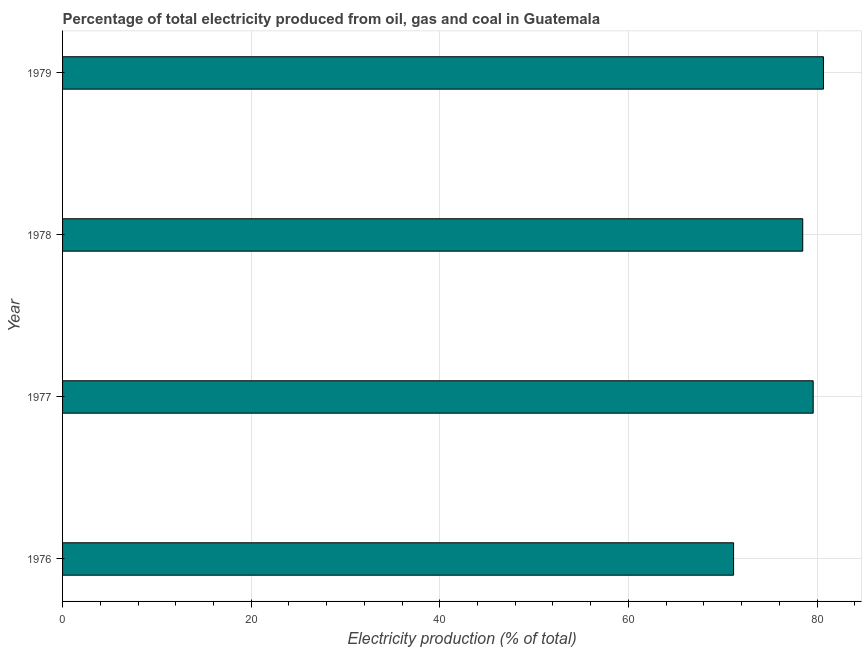Does the graph contain grids?
Provide a short and direct response. Yes. What is the title of the graph?
Keep it short and to the point. Percentage of total electricity produced from oil, gas and coal in Guatemala. What is the label or title of the X-axis?
Provide a succinct answer. Electricity production (% of total). What is the label or title of the Y-axis?
Your answer should be compact. Year. What is the electricity production in 1977?
Give a very brief answer. 79.59. Across all years, what is the maximum electricity production?
Your answer should be compact. 80.68. Across all years, what is the minimum electricity production?
Keep it short and to the point. 71.15. In which year was the electricity production maximum?
Your answer should be very brief. 1979. In which year was the electricity production minimum?
Provide a succinct answer. 1976. What is the sum of the electricity production?
Give a very brief answer. 309.9. What is the difference between the electricity production in 1976 and 1977?
Offer a terse response. -8.44. What is the average electricity production per year?
Make the answer very short. 77.47. What is the median electricity production?
Offer a very short reply. 79.04. In how many years, is the electricity production greater than 64 %?
Give a very brief answer. 4. Do a majority of the years between 1976 and 1979 (inclusive) have electricity production greater than 12 %?
Provide a short and direct response. Yes. What is the ratio of the electricity production in 1976 to that in 1978?
Give a very brief answer. 0.91. Is the electricity production in 1976 less than that in 1978?
Your answer should be very brief. Yes. Is the difference between the electricity production in 1978 and 1979 greater than the difference between any two years?
Give a very brief answer. No. What is the difference between the highest and the second highest electricity production?
Make the answer very short. 1.09. What is the difference between the highest and the lowest electricity production?
Your answer should be compact. 9.53. In how many years, is the electricity production greater than the average electricity production taken over all years?
Your answer should be very brief. 3. How many years are there in the graph?
Keep it short and to the point. 4. What is the difference between two consecutive major ticks on the X-axis?
Make the answer very short. 20. Are the values on the major ticks of X-axis written in scientific E-notation?
Provide a short and direct response. No. What is the Electricity production (% of total) in 1976?
Keep it short and to the point. 71.15. What is the Electricity production (% of total) in 1977?
Make the answer very short. 79.59. What is the Electricity production (% of total) in 1978?
Your answer should be compact. 78.48. What is the Electricity production (% of total) in 1979?
Ensure brevity in your answer.  80.68. What is the difference between the Electricity production (% of total) in 1976 and 1977?
Make the answer very short. -8.44. What is the difference between the Electricity production (% of total) in 1976 and 1978?
Give a very brief answer. -7.33. What is the difference between the Electricity production (% of total) in 1976 and 1979?
Offer a very short reply. -9.53. What is the difference between the Electricity production (% of total) in 1977 and 1978?
Ensure brevity in your answer.  1.11. What is the difference between the Electricity production (% of total) in 1977 and 1979?
Your answer should be compact. -1.09. What is the difference between the Electricity production (% of total) in 1978 and 1979?
Make the answer very short. -2.2. What is the ratio of the Electricity production (% of total) in 1976 to that in 1977?
Your answer should be compact. 0.89. What is the ratio of the Electricity production (% of total) in 1976 to that in 1978?
Your answer should be compact. 0.91. What is the ratio of the Electricity production (% of total) in 1976 to that in 1979?
Offer a very short reply. 0.88. What is the ratio of the Electricity production (% of total) in 1977 to that in 1979?
Keep it short and to the point. 0.99. What is the ratio of the Electricity production (% of total) in 1978 to that in 1979?
Your answer should be compact. 0.97. 